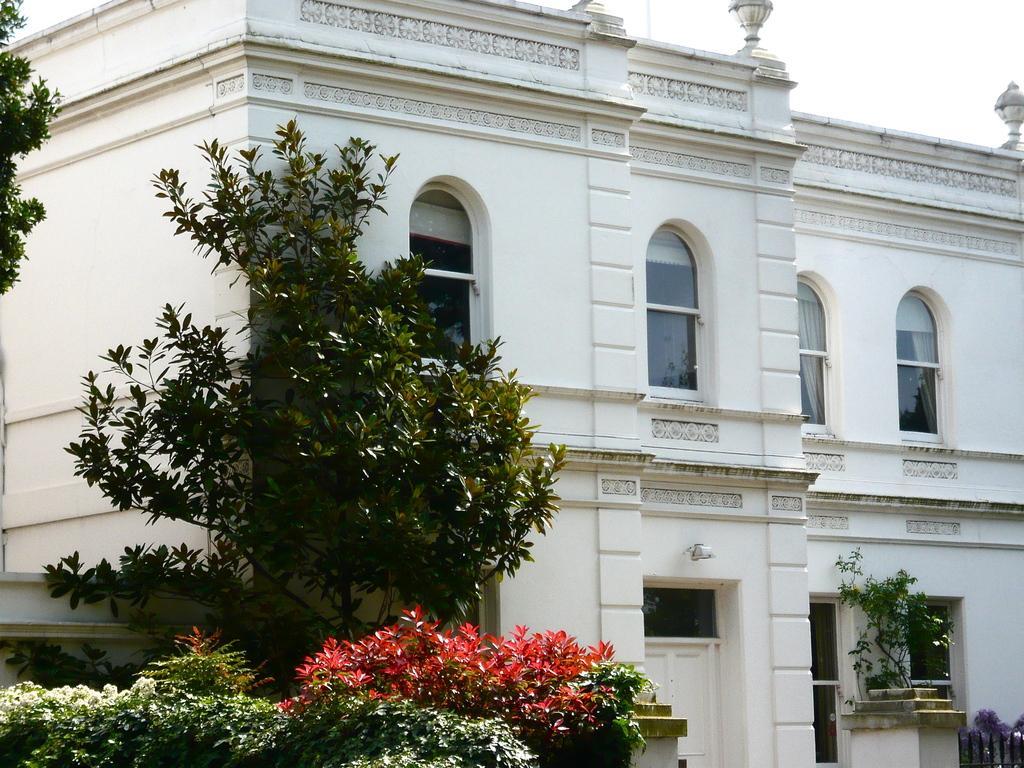Can you describe this image briefly? In this image we can see buildings and windows. On the left there are trees and bushes. At the top there is sky. 